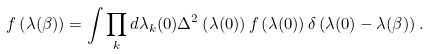<formula> <loc_0><loc_0><loc_500><loc_500>f \left ( \lambda ( \beta ) \right ) = \int \prod _ { k } d \lambda _ { k } ( 0 ) \Delta ^ { 2 } \left ( \lambda ( 0 ) \right ) f \left ( \lambda ( 0 ) \right ) \delta \left ( \lambda ( 0 ) - \lambda ( \beta ) \right ) .</formula> 